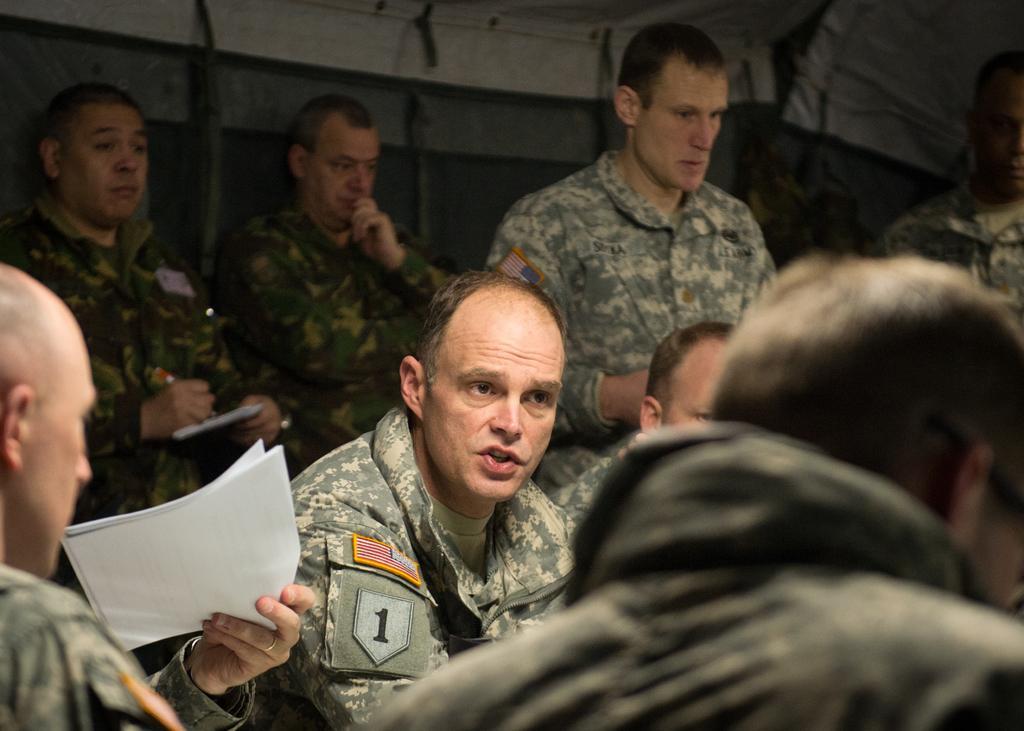Please provide a concise description of this image. In this image we can see a group of people, some people are sitting. On the left side of the image we can see a hand of a person holding paper and a person standing is holding a pen and paper in his hands. At the top of the image we can see the tent. 